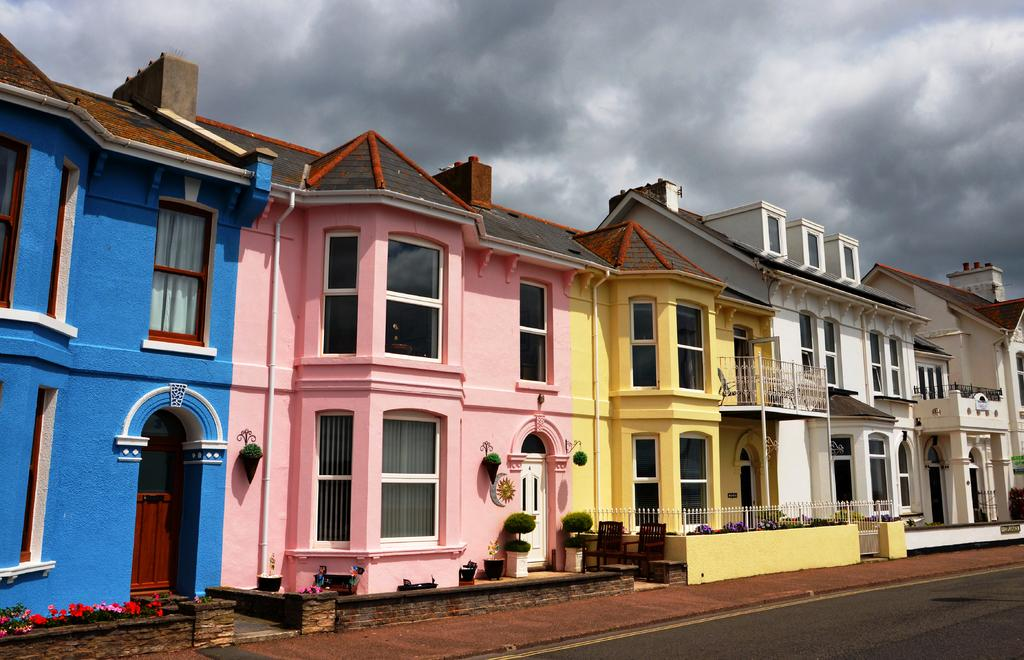What type of structures can be seen in the image? There are roof houses in the image. What else is present in the image besides the houses? There are plants and a road in the image. What is visible in the sky in the image? There are clouds in the sky. What type of skin condition can be seen on the plants in the image? There is no skin condition present on the plants in the image, as plants do not have skin. 